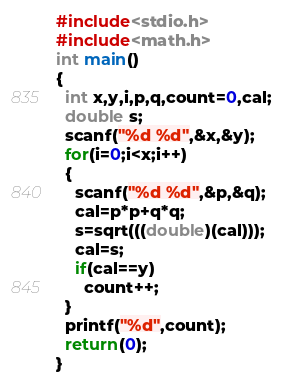Convert code to text. <code><loc_0><loc_0><loc_500><loc_500><_C_>#include<stdio.h>
#include<math.h>
int main()
{
  int x,y,i,p,q,count=0,cal;
  double s;
  scanf("%d %d",&x,&y);
  for(i=0;i<x;i++)
  {
    scanf("%d %d",&p,&q);
    cal=p*p+q*q;
    s=sqrt(((double)(cal)));
    cal=s;
    if(cal==y)
      count++;
  }
  printf("%d",count);
  return(0);
}</code> 